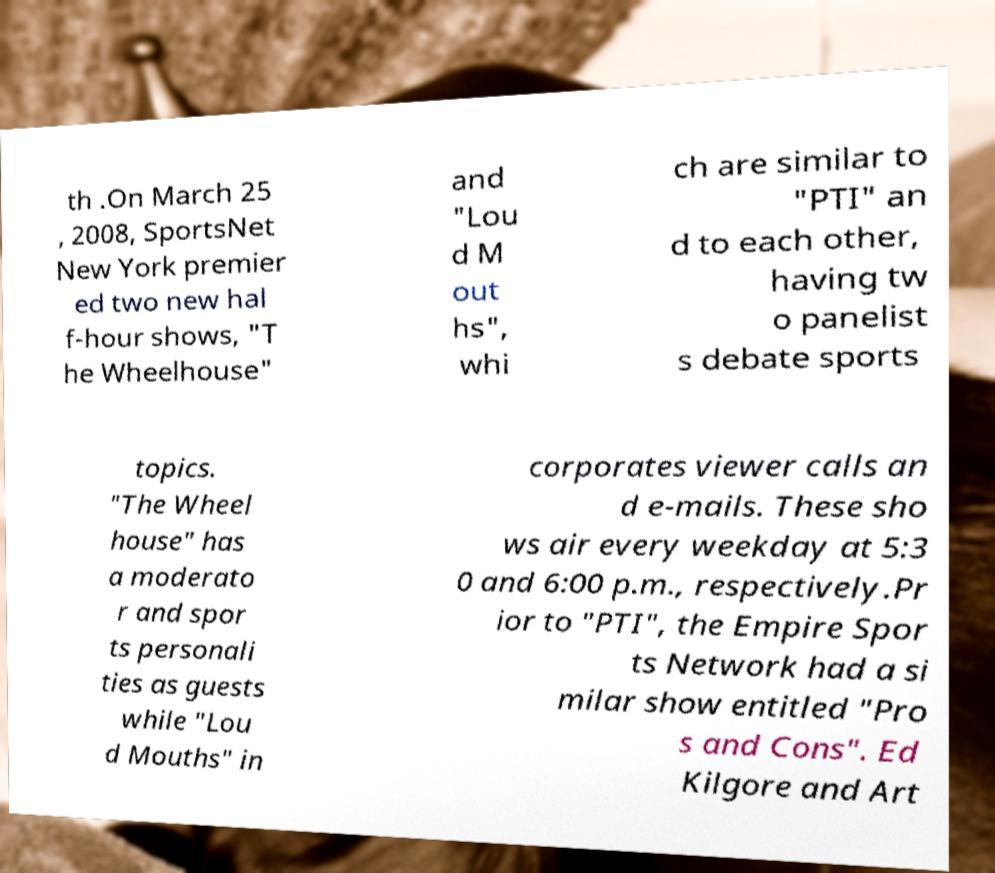For documentation purposes, I need the text within this image transcribed. Could you provide that? th .On March 25 , 2008, SportsNet New York premier ed two new hal f-hour shows, "T he Wheelhouse" and "Lou d M out hs", whi ch are similar to "PTI" an d to each other, having tw o panelist s debate sports topics. "The Wheel house" has a moderato r and spor ts personali ties as guests while "Lou d Mouths" in corporates viewer calls an d e-mails. These sho ws air every weekday at 5:3 0 and 6:00 p.m., respectively.Pr ior to "PTI", the Empire Spor ts Network had a si milar show entitled "Pro s and Cons". Ed Kilgore and Art 